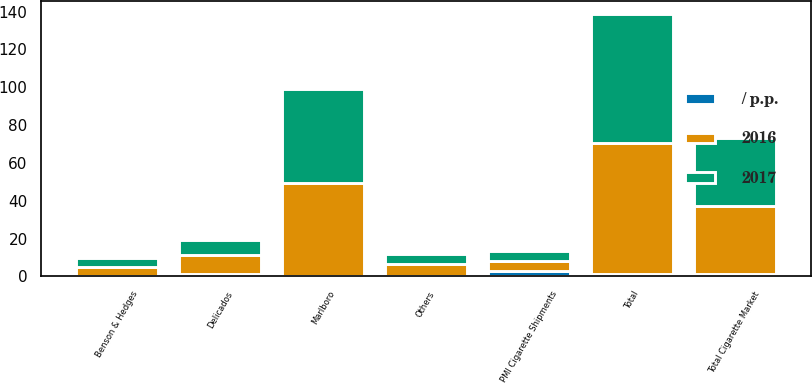<chart> <loc_0><loc_0><loc_500><loc_500><stacked_bar_chart><ecel><fcel>Total Cigarette Market<fcel>PMI Cigarette Shipments<fcel>Marlboro<fcel>Delicados<fcel>Benson & Hedges<fcel>Others<fcel>Total<nl><fcel>2017<fcel>35.8<fcel>5.4<fcel>49.4<fcel>8.3<fcel>5<fcel>5.4<fcel>68.1<nl><fcel>2016<fcel>36.2<fcel>5.4<fcel>49<fcel>9.7<fcel>4.7<fcel>5.9<fcel>69.3<nl><fcel>/ p.p.<fcel>1.1<fcel>2.9<fcel>0.4<fcel>1.4<fcel>0.3<fcel>0.5<fcel>1.2<nl></chart> 